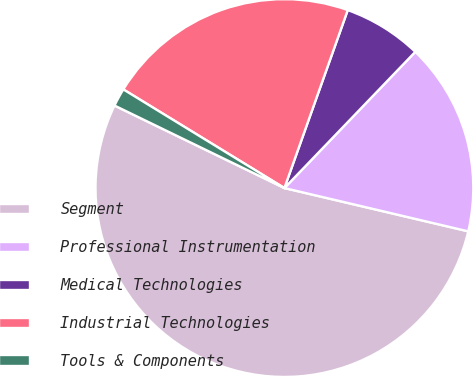Convert chart to OTSL. <chart><loc_0><loc_0><loc_500><loc_500><pie_chart><fcel>Segment<fcel>Professional Instrumentation<fcel>Medical Technologies<fcel>Industrial Technologies<fcel>Tools & Components<nl><fcel>53.52%<fcel>16.5%<fcel>6.74%<fcel>21.7%<fcel>1.55%<nl></chart> 